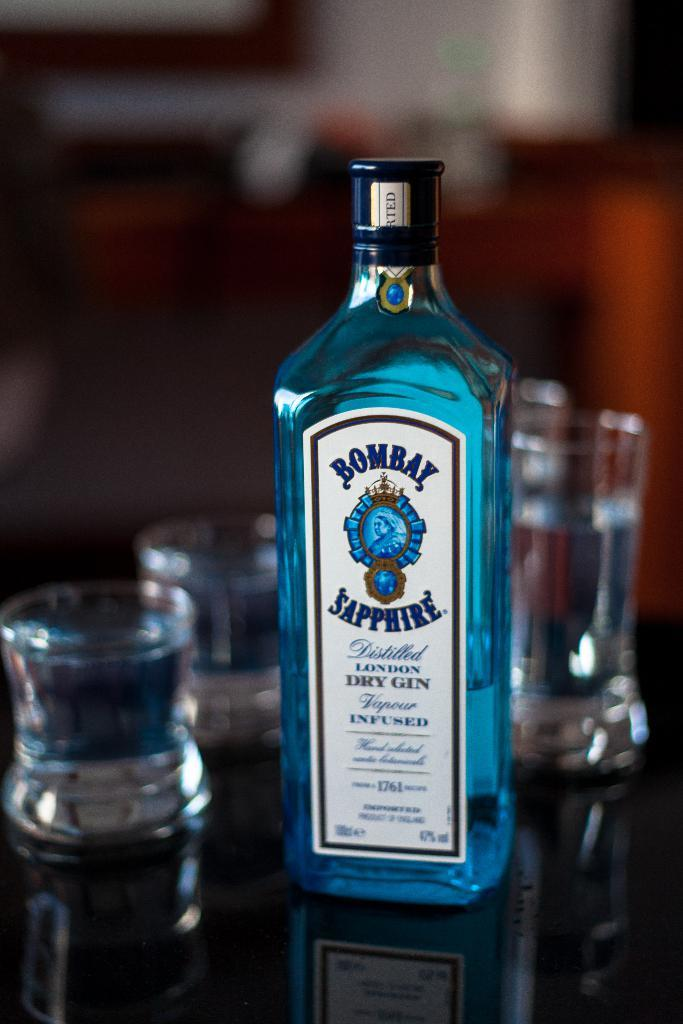<image>
Offer a succinct explanation of the picture presented. A group of glasses and a bottle of blue Bombay Sapphire. 